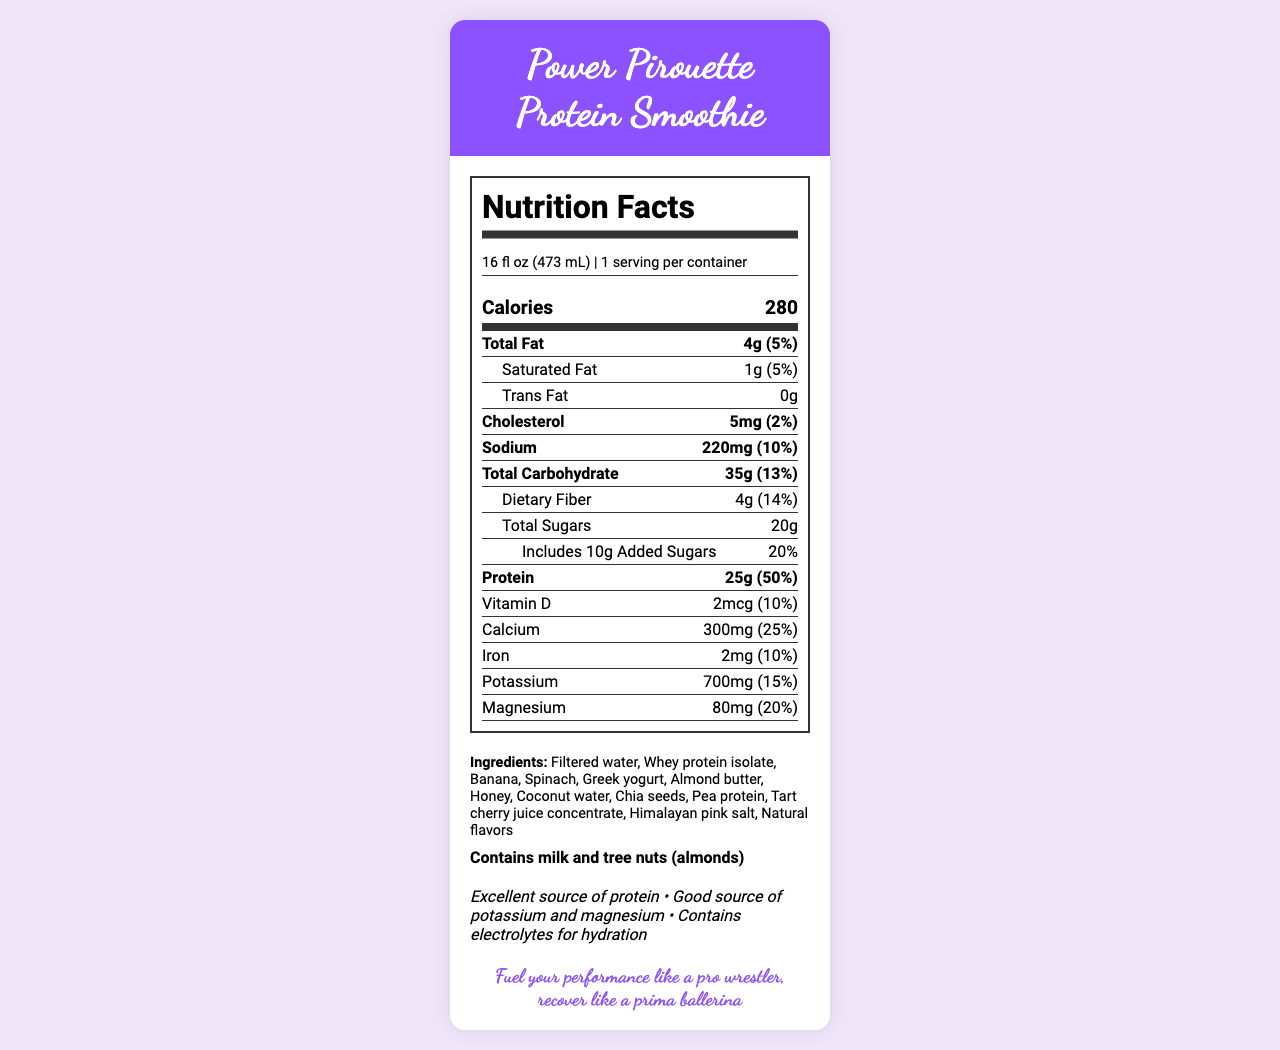what is the serving size of the Power Pirouette Protein Smoothie? The serving size is clearly stated at the top of the nutrition facts section.
Answer: 16 fl oz (473 mL) How many calories are in one serving of the Power Pirouette Protein Smoothie? The calorie count is displayed prominently in the calorie information section.
Answer: 280 What is the total fat content per serving? The total fat content can be found in the nutrient-info section under "Total Fat."
Answer: 4g How much protein is in one serving of the smoothie? The protein amount is specifically highlighted in the bold nutrient-info section.
Answer: 25g Which ingredient is listed first in the ingredients list? The ingredients are listed in order of abundance, starting with filtered water.
Answer: Filtered water How many grams of dietary fiber are in the smoothie? The dietary fiber content is listed under the total carbohydrate section.
Answer: 4g What percentage of the daily value for calcium does the smoothie provide? A. 10% B. 20% C. 25% D. 50% The daily value percentage for calcium is 25%, as listed in the nutrient-info section.
Answer: C. 25% What are the allergens mentioned on the label? A. Milk and peanuts B. Eggs and tree nuts C. Milk and tree nuts D. Soy and gluten The allergens are listed in the allergens section, specifically mentioning milk and tree nuts (almonds).
Answer: C. Milk and tree nuts Does the Power Pirouette Protein Smoothie contain any added sugars? The label indicates it includes 10g of added sugars in the total sugars section.
Answer: Yes How much potassium does this smoothie provide? The potassium content is listed in the nutrient-info section.
Answer: 700mg Summarize the main nutritional benefits of the Power Pirouette Protein Smoothie. The summary includes the main nutritional highlights and claims of the smoothie which are specified on the Nutrition Facts Label and in the claims section.
Answer: The Power Pirouette Protein Smoothie provides high protein content, electrolytes for hydration, and is a good source of potassium and magnesium. It also contains dietary fiber and important vitamins and minerals such as calcium, iron, and vitamin D. How much cholesterol does the smoothie contain? The cholesterol content is found in the bold nutrient-info section under cholesterol.
Answer: 5mg Can you determine the flavor of the smoothie from the document? The document lists ingredients and nutritional information but does not specify the flavor of the smoothie.
Answer: Not enough information Does the smoothie contain any trans fat? The nutrition info specifies that the total trans fat is 0g.
Answer: No Which of the following sound like potential benefits mentioned in the claims?
A. Improves digestion
B. Aids muscle recovery
C. Contains electrolytes for hydration
D. Enhances brain function The claims section mentions that the smoothie is an excellent source of protein and contains electrolytes for hydration, both related to muscle recovery and hydration.
Answer: B. Aids muscle recovery & C. Contains electrolytes for hydration 